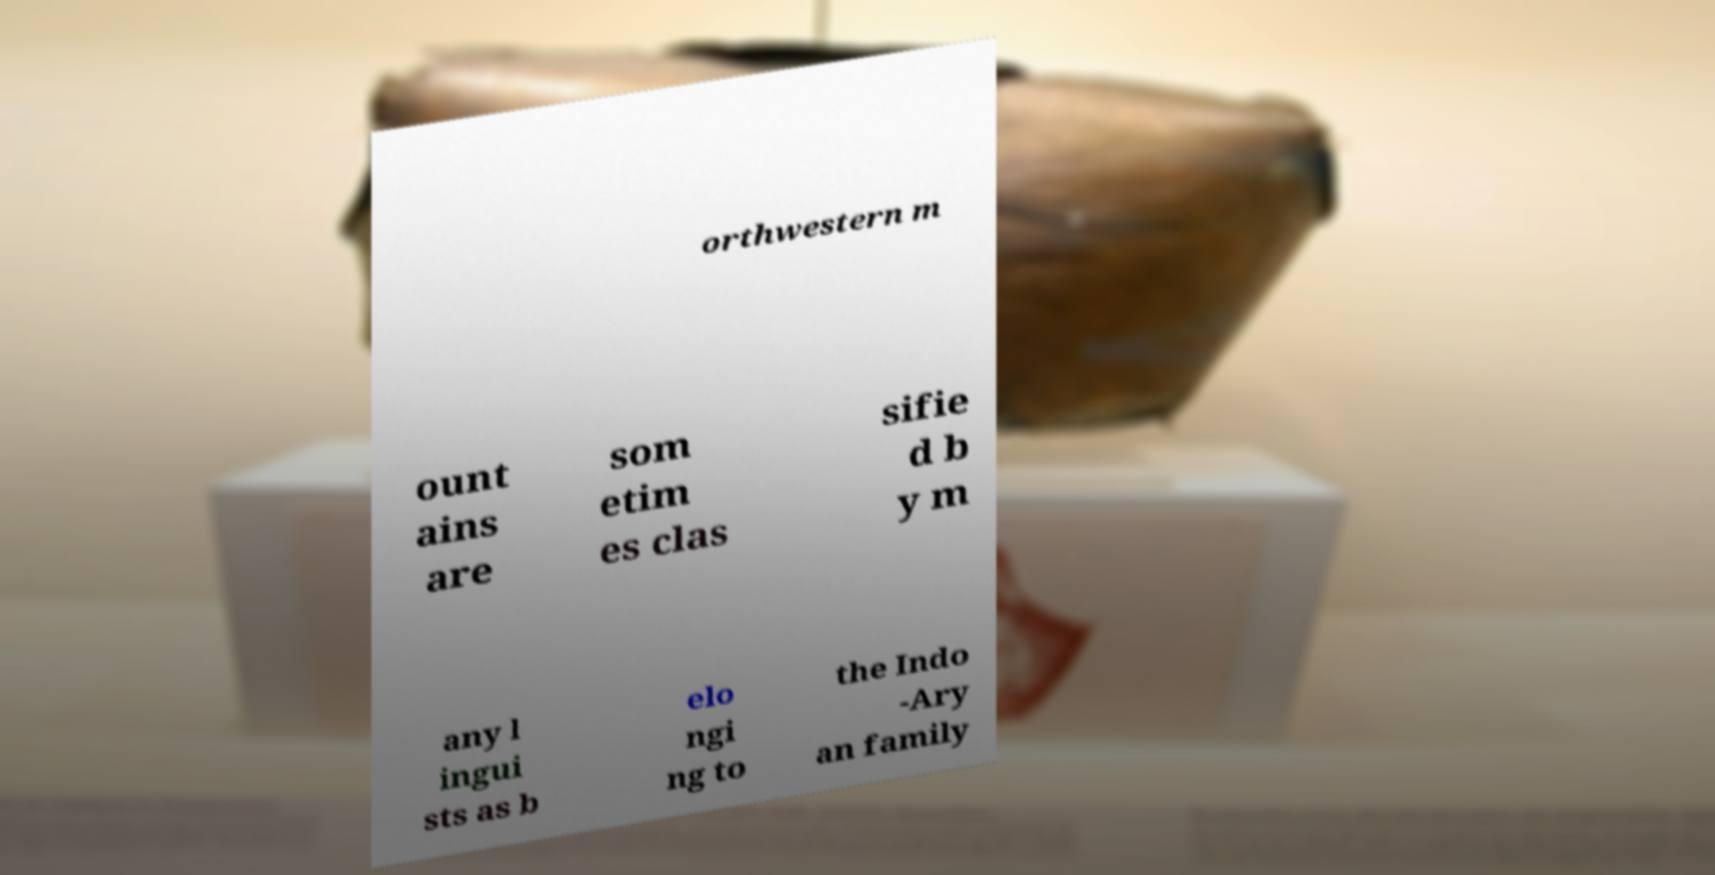I need the written content from this picture converted into text. Can you do that? orthwestern m ount ains are som etim es clas sifie d b y m any l ingui sts as b elo ngi ng to the Indo -Ary an family 